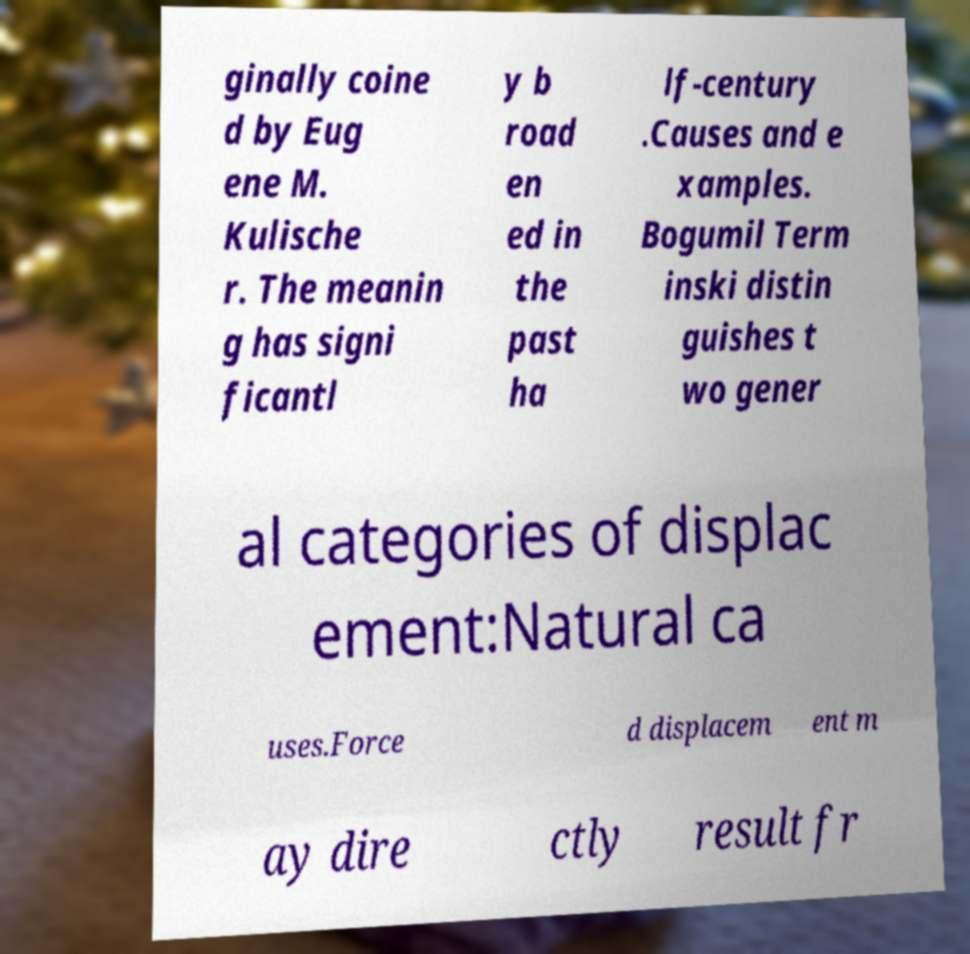Can you read and provide the text displayed in the image?This photo seems to have some interesting text. Can you extract and type it out for me? ginally coine d by Eug ene M. Kulische r. The meanin g has signi ficantl y b road en ed in the past ha lf-century .Causes and e xamples. Bogumil Term inski distin guishes t wo gener al categories of displac ement:Natural ca uses.Force d displacem ent m ay dire ctly result fr 